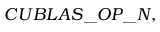<formula> <loc_0><loc_0><loc_500><loc_500>C U B L A S \_ O P \_ N ,</formula> 